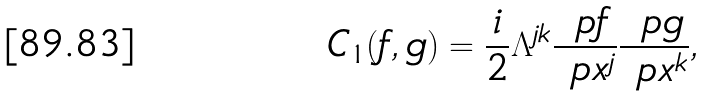Convert formula to latex. <formula><loc_0><loc_0><loc_500><loc_500>C _ { 1 } ( f , g ) = \frac { i } { 2 } \Lambda ^ { j k } \frac { \ p f } { \ p x ^ { j } } \frac { \ p g } { \ p x ^ { k } } ,</formula> 